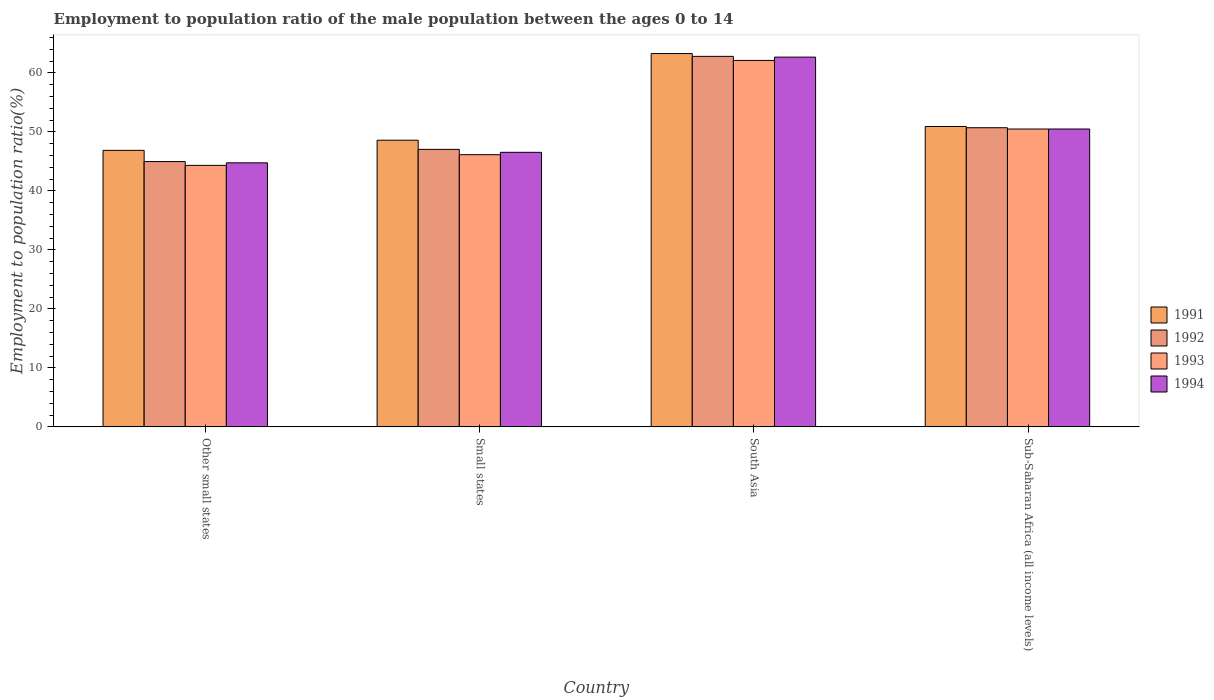Are the number of bars per tick equal to the number of legend labels?
Offer a very short reply. Yes. How many bars are there on the 2nd tick from the left?
Keep it short and to the point. 4. How many bars are there on the 3rd tick from the right?
Your answer should be very brief. 4. What is the label of the 1st group of bars from the left?
Your answer should be compact. Other small states. In how many cases, is the number of bars for a given country not equal to the number of legend labels?
Your answer should be compact. 0. What is the employment to population ratio in 1993 in South Asia?
Make the answer very short. 62.11. Across all countries, what is the maximum employment to population ratio in 1994?
Offer a terse response. 62.67. Across all countries, what is the minimum employment to population ratio in 1994?
Keep it short and to the point. 44.75. In which country was the employment to population ratio in 1993 minimum?
Your answer should be very brief. Other small states. What is the total employment to population ratio in 1993 in the graph?
Your response must be concise. 203.03. What is the difference between the employment to population ratio in 1993 in Other small states and that in Small states?
Your answer should be compact. -1.81. What is the difference between the employment to population ratio in 1994 in Other small states and the employment to population ratio in 1992 in Small states?
Provide a short and direct response. -2.28. What is the average employment to population ratio in 1993 per country?
Your response must be concise. 50.76. What is the difference between the employment to population ratio of/in 1994 and employment to population ratio of/in 1991 in Other small states?
Provide a short and direct response. -2.11. In how many countries, is the employment to population ratio in 1993 greater than 60 %?
Your answer should be compact. 1. What is the ratio of the employment to population ratio in 1991 in Small states to that in South Asia?
Your answer should be very brief. 0.77. Is the employment to population ratio in 1994 in Other small states less than that in Sub-Saharan Africa (all income levels)?
Give a very brief answer. Yes. Is the difference between the employment to population ratio in 1994 in South Asia and Sub-Saharan Africa (all income levels) greater than the difference between the employment to population ratio in 1991 in South Asia and Sub-Saharan Africa (all income levels)?
Provide a succinct answer. No. What is the difference between the highest and the second highest employment to population ratio in 1994?
Offer a very short reply. -3.95. What is the difference between the highest and the lowest employment to population ratio in 1993?
Make the answer very short. 17.79. Is it the case that in every country, the sum of the employment to population ratio in 1992 and employment to population ratio in 1994 is greater than the sum of employment to population ratio in 1993 and employment to population ratio in 1991?
Your answer should be compact. No. What does the 2nd bar from the left in Other small states represents?
Your response must be concise. 1992. What does the 1st bar from the right in Other small states represents?
Give a very brief answer. 1994. Is it the case that in every country, the sum of the employment to population ratio in 1992 and employment to population ratio in 1991 is greater than the employment to population ratio in 1994?
Offer a very short reply. Yes. How many bars are there?
Give a very brief answer. 16. How many countries are there in the graph?
Provide a short and direct response. 4. What is the difference between two consecutive major ticks on the Y-axis?
Provide a short and direct response. 10. How many legend labels are there?
Your answer should be compact. 4. What is the title of the graph?
Offer a very short reply. Employment to population ratio of the male population between the ages 0 to 14. Does "1980" appear as one of the legend labels in the graph?
Offer a very short reply. No. What is the label or title of the X-axis?
Give a very brief answer. Country. What is the label or title of the Y-axis?
Give a very brief answer. Employment to population ratio(%). What is the Employment to population ratio(%) in 1991 in Other small states?
Make the answer very short. 46.86. What is the Employment to population ratio(%) in 1992 in Other small states?
Your response must be concise. 44.96. What is the Employment to population ratio(%) in 1993 in Other small states?
Provide a succinct answer. 44.32. What is the Employment to population ratio(%) in 1994 in Other small states?
Keep it short and to the point. 44.75. What is the Employment to population ratio(%) in 1991 in Small states?
Your response must be concise. 48.58. What is the Employment to population ratio(%) in 1992 in Small states?
Offer a very short reply. 47.03. What is the Employment to population ratio(%) in 1993 in Small states?
Ensure brevity in your answer.  46.13. What is the Employment to population ratio(%) of 1994 in Small states?
Make the answer very short. 46.53. What is the Employment to population ratio(%) in 1991 in South Asia?
Give a very brief answer. 63.27. What is the Employment to population ratio(%) of 1992 in South Asia?
Your answer should be compact. 62.79. What is the Employment to population ratio(%) in 1993 in South Asia?
Your answer should be compact. 62.11. What is the Employment to population ratio(%) in 1994 in South Asia?
Your answer should be very brief. 62.67. What is the Employment to population ratio(%) in 1991 in Sub-Saharan Africa (all income levels)?
Your answer should be very brief. 50.91. What is the Employment to population ratio(%) of 1992 in Sub-Saharan Africa (all income levels)?
Offer a terse response. 50.7. What is the Employment to population ratio(%) of 1993 in Sub-Saharan Africa (all income levels)?
Keep it short and to the point. 50.48. What is the Employment to population ratio(%) of 1994 in Sub-Saharan Africa (all income levels)?
Your answer should be very brief. 50.48. Across all countries, what is the maximum Employment to population ratio(%) in 1991?
Your answer should be compact. 63.27. Across all countries, what is the maximum Employment to population ratio(%) in 1992?
Offer a very short reply. 62.79. Across all countries, what is the maximum Employment to population ratio(%) of 1993?
Ensure brevity in your answer.  62.11. Across all countries, what is the maximum Employment to population ratio(%) of 1994?
Keep it short and to the point. 62.67. Across all countries, what is the minimum Employment to population ratio(%) of 1991?
Offer a very short reply. 46.86. Across all countries, what is the minimum Employment to population ratio(%) in 1992?
Provide a short and direct response. 44.96. Across all countries, what is the minimum Employment to population ratio(%) in 1993?
Provide a short and direct response. 44.32. Across all countries, what is the minimum Employment to population ratio(%) in 1994?
Your answer should be very brief. 44.75. What is the total Employment to population ratio(%) of 1991 in the graph?
Provide a short and direct response. 209.62. What is the total Employment to population ratio(%) in 1992 in the graph?
Ensure brevity in your answer.  205.49. What is the total Employment to population ratio(%) in 1993 in the graph?
Your response must be concise. 203.03. What is the total Employment to population ratio(%) in 1994 in the graph?
Make the answer very short. 204.43. What is the difference between the Employment to population ratio(%) in 1991 in Other small states and that in Small states?
Keep it short and to the point. -1.72. What is the difference between the Employment to population ratio(%) in 1992 in Other small states and that in Small states?
Make the answer very short. -2.07. What is the difference between the Employment to population ratio(%) in 1993 in Other small states and that in Small states?
Your answer should be compact. -1.81. What is the difference between the Employment to population ratio(%) in 1994 in Other small states and that in Small states?
Offer a very short reply. -1.78. What is the difference between the Employment to population ratio(%) of 1991 in Other small states and that in South Asia?
Make the answer very short. -16.41. What is the difference between the Employment to population ratio(%) of 1992 in Other small states and that in South Asia?
Offer a very short reply. -17.83. What is the difference between the Employment to population ratio(%) in 1993 in Other small states and that in South Asia?
Provide a short and direct response. -17.79. What is the difference between the Employment to population ratio(%) in 1994 in Other small states and that in South Asia?
Offer a very short reply. -17.92. What is the difference between the Employment to population ratio(%) in 1991 in Other small states and that in Sub-Saharan Africa (all income levels)?
Ensure brevity in your answer.  -4.04. What is the difference between the Employment to population ratio(%) of 1992 in Other small states and that in Sub-Saharan Africa (all income levels)?
Offer a very short reply. -5.74. What is the difference between the Employment to population ratio(%) in 1993 in Other small states and that in Sub-Saharan Africa (all income levels)?
Keep it short and to the point. -6.16. What is the difference between the Employment to population ratio(%) of 1994 in Other small states and that in Sub-Saharan Africa (all income levels)?
Provide a succinct answer. -5.73. What is the difference between the Employment to population ratio(%) of 1991 in Small states and that in South Asia?
Your response must be concise. -14.69. What is the difference between the Employment to population ratio(%) of 1992 in Small states and that in South Asia?
Offer a very short reply. -15.76. What is the difference between the Employment to population ratio(%) of 1993 in Small states and that in South Asia?
Offer a terse response. -15.98. What is the difference between the Employment to population ratio(%) in 1994 in Small states and that in South Asia?
Your response must be concise. -16.13. What is the difference between the Employment to population ratio(%) of 1991 in Small states and that in Sub-Saharan Africa (all income levels)?
Your answer should be compact. -2.32. What is the difference between the Employment to population ratio(%) of 1992 in Small states and that in Sub-Saharan Africa (all income levels)?
Offer a terse response. -3.67. What is the difference between the Employment to population ratio(%) of 1993 in Small states and that in Sub-Saharan Africa (all income levels)?
Provide a short and direct response. -4.35. What is the difference between the Employment to population ratio(%) of 1994 in Small states and that in Sub-Saharan Africa (all income levels)?
Offer a terse response. -3.95. What is the difference between the Employment to population ratio(%) of 1991 in South Asia and that in Sub-Saharan Africa (all income levels)?
Your response must be concise. 12.37. What is the difference between the Employment to population ratio(%) of 1992 in South Asia and that in Sub-Saharan Africa (all income levels)?
Ensure brevity in your answer.  12.09. What is the difference between the Employment to population ratio(%) in 1993 in South Asia and that in Sub-Saharan Africa (all income levels)?
Provide a short and direct response. 11.62. What is the difference between the Employment to population ratio(%) of 1994 in South Asia and that in Sub-Saharan Africa (all income levels)?
Offer a very short reply. 12.18. What is the difference between the Employment to population ratio(%) in 1991 in Other small states and the Employment to population ratio(%) in 1992 in Small states?
Your response must be concise. -0.17. What is the difference between the Employment to population ratio(%) in 1991 in Other small states and the Employment to population ratio(%) in 1993 in Small states?
Provide a short and direct response. 0.74. What is the difference between the Employment to population ratio(%) in 1991 in Other small states and the Employment to population ratio(%) in 1994 in Small states?
Keep it short and to the point. 0.33. What is the difference between the Employment to population ratio(%) in 1992 in Other small states and the Employment to population ratio(%) in 1993 in Small states?
Provide a succinct answer. -1.16. What is the difference between the Employment to population ratio(%) of 1992 in Other small states and the Employment to population ratio(%) of 1994 in Small states?
Make the answer very short. -1.57. What is the difference between the Employment to population ratio(%) of 1993 in Other small states and the Employment to population ratio(%) of 1994 in Small states?
Your answer should be very brief. -2.21. What is the difference between the Employment to population ratio(%) in 1991 in Other small states and the Employment to population ratio(%) in 1992 in South Asia?
Give a very brief answer. -15.93. What is the difference between the Employment to population ratio(%) in 1991 in Other small states and the Employment to population ratio(%) in 1993 in South Asia?
Provide a succinct answer. -15.24. What is the difference between the Employment to population ratio(%) of 1991 in Other small states and the Employment to population ratio(%) of 1994 in South Asia?
Your answer should be compact. -15.8. What is the difference between the Employment to population ratio(%) of 1992 in Other small states and the Employment to population ratio(%) of 1993 in South Asia?
Provide a short and direct response. -17.14. What is the difference between the Employment to population ratio(%) in 1992 in Other small states and the Employment to population ratio(%) in 1994 in South Asia?
Ensure brevity in your answer.  -17.7. What is the difference between the Employment to population ratio(%) in 1993 in Other small states and the Employment to population ratio(%) in 1994 in South Asia?
Your response must be concise. -18.35. What is the difference between the Employment to population ratio(%) of 1991 in Other small states and the Employment to population ratio(%) of 1992 in Sub-Saharan Africa (all income levels)?
Your answer should be very brief. -3.84. What is the difference between the Employment to population ratio(%) of 1991 in Other small states and the Employment to population ratio(%) of 1993 in Sub-Saharan Africa (all income levels)?
Your response must be concise. -3.62. What is the difference between the Employment to population ratio(%) in 1991 in Other small states and the Employment to population ratio(%) in 1994 in Sub-Saharan Africa (all income levels)?
Give a very brief answer. -3.62. What is the difference between the Employment to population ratio(%) in 1992 in Other small states and the Employment to population ratio(%) in 1993 in Sub-Saharan Africa (all income levels)?
Your answer should be compact. -5.52. What is the difference between the Employment to population ratio(%) in 1992 in Other small states and the Employment to population ratio(%) in 1994 in Sub-Saharan Africa (all income levels)?
Make the answer very short. -5.52. What is the difference between the Employment to population ratio(%) of 1993 in Other small states and the Employment to population ratio(%) of 1994 in Sub-Saharan Africa (all income levels)?
Provide a short and direct response. -6.16. What is the difference between the Employment to population ratio(%) in 1991 in Small states and the Employment to population ratio(%) in 1992 in South Asia?
Keep it short and to the point. -14.21. What is the difference between the Employment to population ratio(%) of 1991 in Small states and the Employment to population ratio(%) of 1993 in South Asia?
Your answer should be very brief. -13.52. What is the difference between the Employment to population ratio(%) in 1991 in Small states and the Employment to population ratio(%) in 1994 in South Asia?
Make the answer very short. -14.08. What is the difference between the Employment to population ratio(%) in 1992 in Small states and the Employment to population ratio(%) in 1993 in South Asia?
Offer a terse response. -15.07. What is the difference between the Employment to population ratio(%) of 1992 in Small states and the Employment to population ratio(%) of 1994 in South Asia?
Offer a terse response. -15.63. What is the difference between the Employment to population ratio(%) in 1993 in Small states and the Employment to population ratio(%) in 1994 in South Asia?
Provide a short and direct response. -16.54. What is the difference between the Employment to population ratio(%) in 1991 in Small states and the Employment to population ratio(%) in 1992 in Sub-Saharan Africa (all income levels)?
Offer a terse response. -2.12. What is the difference between the Employment to population ratio(%) of 1991 in Small states and the Employment to population ratio(%) of 1993 in Sub-Saharan Africa (all income levels)?
Offer a terse response. -1.9. What is the difference between the Employment to population ratio(%) in 1991 in Small states and the Employment to population ratio(%) in 1994 in Sub-Saharan Africa (all income levels)?
Provide a succinct answer. -1.9. What is the difference between the Employment to population ratio(%) in 1992 in Small states and the Employment to population ratio(%) in 1993 in Sub-Saharan Africa (all income levels)?
Ensure brevity in your answer.  -3.45. What is the difference between the Employment to population ratio(%) of 1992 in Small states and the Employment to population ratio(%) of 1994 in Sub-Saharan Africa (all income levels)?
Offer a very short reply. -3.45. What is the difference between the Employment to population ratio(%) in 1993 in Small states and the Employment to population ratio(%) in 1994 in Sub-Saharan Africa (all income levels)?
Offer a terse response. -4.36. What is the difference between the Employment to population ratio(%) in 1991 in South Asia and the Employment to population ratio(%) in 1992 in Sub-Saharan Africa (all income levels)?
Offer a terse response. 12.57. What is the difference between the Employment to population ratio(%) in 1991 in South Asia and the Employment to population ratio(%) in 1993 in Sub-Saharan Africa (all income levels)?
Your answer should be compact. 12.79. What is the difference between the Employment to population ratio(%) in 1991 in South Asia and the Employment to population ratio(%) in 1994 in Sub-Saharan Africa (all income levels)?
Give a very brief answer. 12.79. What is the difference between the Employment to population ratio(%) of 1992 in South Asia and the Employment to population ratio(%) of 1993 in Sub-Saharan Africa (all income levels)?
Provide a succinct answer. 12.31. What is the difference between the Employment to population ratio(%) in 1992 in South Asia and the Employment to population ratio(%) in 1994 in Sub-Saharan Africa (all income levels)?
Your answer should be compact. 12.31. What is the difference between the Employment to population ratio(%) of 1993 in South Asia and the Employment to population ratio(%) of 1994 in Sub-Saharan Africa (all income levels)?
Keep it short and to the point. 11.62. What is the average Employment to population ratio(%) of 1991 per country?
Provide a short and direct response. 52.41. What is the average Employment to population ratio(%) in 1992 per country?
Your answer should be very brief. 51.37. What is the average Employment to population ratio(%) in 1993 per country?
Ensure brevity in your answer.  50.76. What is the average Employment to population ratio(%) of 1994 per country?
Your answer should be compact. 51.11. What is the difference between the Employment to population ratio(%) in 1991 and Employment to population ratio(%) in 1992 in Other small states?
Offer a very short reply. 1.9. What is the difference between the Employment to population ratio(%) in 1991 and Employment to population ratio(%) in 1993 in Other small states?
Provide a succinct answer. 2.54. What is the difference between the Employment to population ratio(%) in 1991 and Employment to population ratio(%) in 1994 in Other small states?
Make the answer very short. 2.11. What is the difference between the Employment to population ratio(%) of 1992 and Employment to population ratio(%) of 1993 in Other small states?
Keep it short and to the point. 0.64. What is the difference between the Employment to population ratio(%) of 1992 and Employment to population ratio(%) of 1994 in Other small states?
Provide a short and direct response. 0.21. What is the difference between the Employment to population ratio(%) in 1993 and Employment to population ratio(%) in 1994 in Other small states?
Provide a succinct answer. -0.43. What is the difference between the Employment to population ratio(%) of 1991 and Employment to population ratio(%) of 1992 in Small states?
Provide a short and direct response. 1.55. What is the difference between the Employment to population ratio(%) in 1991 and Employment to population ratio(%) in 1993 in Small states?
Keep it short and to the point. 2.45. What is the difference between the Employment to population ratio(%) in 1991 and Employment to population ratio(%) in 1994 in Small states?
Provide a short and direct response. 2.05. What is the difference between the Employment to population ratio(%) in 1992 and Employment to population ratio(%) in 1993 in Small states?
Give a very brief answer. 0.9. What is the difference between the Employment to population ratio(%) of 1992 and Employment to population ratio(%) of 1994 in Small states?
Offer a very short reply. 0.5. What is the difference between the Employment to population ratio(%) in 1993 and Employment to population ratio(%) in 1994 in Small states?
Your response must be concise. -0.4. What is the difference between the Employment to population ratio(%) of 1991 and Employment to population ratio(%) of 1992 in South Asia?
Offer a terse response. 0.48. What is the difference between the Employment to population ratio(%) of 1991 and Employment to population ratio(%) of 1993 in South Asia?
Your answer should be very brief. 1.17. What is the difference between the Employment to population ratio(%) in 1991 and Employment to population ratio(%) in 1994 in South Asia?
Offer a very short reply. 0.61. What is the difference between the Employment to population ratio(%) of 1992 and Employment to population ratio(%) of 1993 in South Asia?
Your response must be concise. 0.69. What is the difference between the Employment to population ratio(%) in 1992 and Employment to population ratio(%) in 1994 in South Asia?
Your answer should be very brief. 0.13. What is the difference between the Employment to population ratio(%) in 1993 and Employment to population ratio(%) in 1994 in South Asia?
Offer a very short reply. -0.56. What is the difference between the Employment to population ratio(%) in 1991 and Employment to population ratio(%) in 1992 in Sub-Saharan Africa (all income levels)?
Give a very brief answer. 0.21. What is the difference between the Employment to population ratio(%) in 1991 and Employment to population ratio(%) in 1993 in Sub-Saharan Africa (all income levels)?
Give a very brief answer. 0.43. What is the difference between the Employment to population ratio(%) in 1991 and Employment to population ratio(%) in 1994 in Sub-Saharan Africa (all income levels)?
Offer a terse response. 0.42. What is the difference between the Employment to population ratio(%) of 1992 and Employment to population ratio(%) of 1993 in Sub-Saharan Africa (all income levels)?
Offer a very short reply. 0.22. What is the difference between the Employment to population ratio(%) of 1992 and Employment to population ratio(%) of 1994 in Sub-Saharan Africa (all income levels)?
Provide a succinct answer. 0.22. What is the difference between the Employment to population ratio(%) of 1993 and Employment to population ratio(%) of 1994 in Sub-Saharan Africa (all income levels)?
Give a very brief answer. -0. What is the ratio of the Employment to population ratio(%) of 1991 in Other small states to that in Small states?
Give a very brief answer. 0.96. What is the ratio of the Employment to population ratio(%) of 1992 in Other small states to that in Small states?
Give a very brief answer. 0.96. What is the ratio of the Employment to population ratio(%) in 1993 in Other small states to that in Small states?
Your response must be concise. 0.96. What is the ratio of the Employment to population ratio(%) of 1994 in Other small states to that in Small states?
Keep it short and to the point. 0.96. What is the ratio of the Employment to population ratio(%) of 1991 in Other small states to that in South Asia?
Your answer should be very brief. 0.74. What is the ratio of the Employment to population ratio(%) in 1992 in Other small states to that in South Asia?
Keep it short and to the point. 0.72. What is the ratio of the Employment to population ratio(%) in 1993 in Other small states to that in South Asia?
Provide a short and direct response. 0.71. What is the ratio of the Employment to population ratio(%) of 1994 in Other small states to that in South Asia?
Ensure brevity in your answer.  0.71. What is the ratio of the Employment to population ratio(%) of 1991 in Other small states to that in Sub-Saharan Africa (all income levels)?
Keep it short and to the point. 0.92. What is the ratio of the Employment to population ratio(%) in 1992 in Other small states to that in Sub-Saharan Africa (all income levels)?
Your answer should be very brief. 0.89. What is the ratio of the Employment to population ratio(%) of 1993 in Other small states to that in Sub-Saharan Africa (all income levels)?
Provide a succinct answer. 0.88. What is the ratio of the Employment to population ratio(%) of 1994 in Other small states to that in Sub-Saharan Africa (all income levels)?
Your response must be concise. 0.89. What is the ratio of the Employment to population ratio(%) in 1991 in Small states to that in South Asia?
Provide a short and direct response. 0.77. What is the ratio of the Employment to population ratio(%) of 1992 in Small states to that in South Asia?
Your response must be concise. 0.75. What is the ratio of the Employment to population ratio(%) of 1993 in Small states to that in South Asia?
Provide a short and direct response. 0.74. What is the ratio of the Employment to population ratio(%) in 1994 in Small states to that in South Asia?
Your answer should be compact. 0.74. What is the ratio of the Employment to population ratio(%) in 1991 in Small states to that in Sub-Saharan Africa (all income levels)?
Ensure brevity in your answer.  0.95. What is the ratio of the Employment to population ratio(%) in 1992 in Small states to that in Sub-Saharan Africa (all income levels)?
Give a very brief answer. 0.93. What is the ratio of the Employment to population ratio(%) of 1993 in Small states to that in Sub-Saharan Africa (all income levels)?
Offer a very short reply. 0.91. What is the ratio of the Employment to population ratio(%) of 1994 in Small states to that in Sub-Saharan Africa (all income levels)?
Provide a short and direct response. 0.92. What is the ratio of the Employment to population ratio(%) in 1991 in South Asia to that in Sub-Saharan Africa (all income levels)?
Your answer should be very brief. 1.24. What is the ratio of the Employment to population ratio(%) of 1992 in South Asia to that in Sub-Saharan Africa (all income levels)?
Your answer should be very brief. 1.24. What is the ratio of the Employment to population ratio(%) in 1993 in South Asia to that in Sub-Saharan Africa (all income levels)?
Your response must be concise. 1.23. What is the ratio of the Employment to population ratio(%) in 1994 in South Asia to that in Sub-Saharan Africa (all income levels)?
Your answer should be very brief. 1.24. What is the difference between the highest and the second highest Employment to population ratio(%) of 1991?
Make the answer very short. 12.37. What is the difference between the highest and the second highest Employment to population ratio(%) in 1992?
Your answer should be compact. 12.09. What is the difference between the highest and the second highest Employment to population ratio(%) of 1993?
Provide a short and direct response. 11.62. What is the difference between the highest and the second highest Employment to population ratio(%) of 1994?
Ensure brevity in your answer.  12.18. What is the difference between the highest and the lowest Employment to population ratio(%) of 1991?
Your answer should be compact. 16.41. What is the difference between the highest and the lowest Employment to population ratio(%) in 1992?
Offer a very short reply. 17.83. What is the difference between the highest and the lowest Employment to population ratio(%) in 1993?
Provide a succinct answer. 17.79. What is the difference between the highest and the lowest Employment to population ratio(%) of 1994?
Make the answer very short. 17.92. 